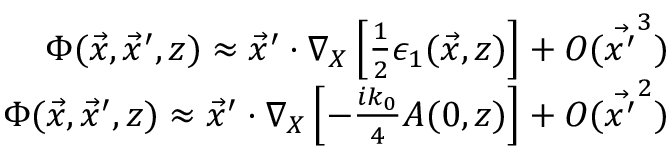<formula> <loc_0><loc_0><loc_500><loc_500>\begin{array} { r } { \Phi ( \vec { x } , \vec { x } ^ { \prime } , z ) \approx \vec { x } ^ { \prime } \cdot \nabla _ { X } \left [ \frac { 1 } { 2 } \epsilon _ { 1 } ( \vec { x } , z ) \right ] + O ( \vec { x ^ { \prime } } ^ { 3 } ) } \\ { \Phi ( \vec { x } , \vec { x } ^ { \prime } , z ) \approx \vec { x } ^ { \prime } \cdot \nabla _ { X } \left [ - \frac { i k _ { 0 } } { 4 } A ( 0 , z ) \right ] + O ( \vec { x ^ { \prime } } ^ { 2 } ) } \end{array}</formula> 